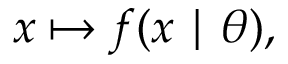<formula> <loc_0><loc_0><loc_500><loc_500>x \mapsto f ( x | \theta ) ,</formula> 